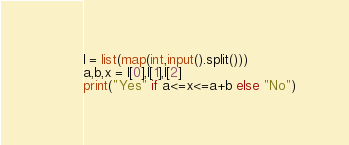<code> <loc_0><loc_0><loc_500><loc_500><_Python_>l = list(map(int,input().split()))
a,b,x = l[0],l[1],l[2]
print("Yes" if a<=x<=a+b else "No")</code> 